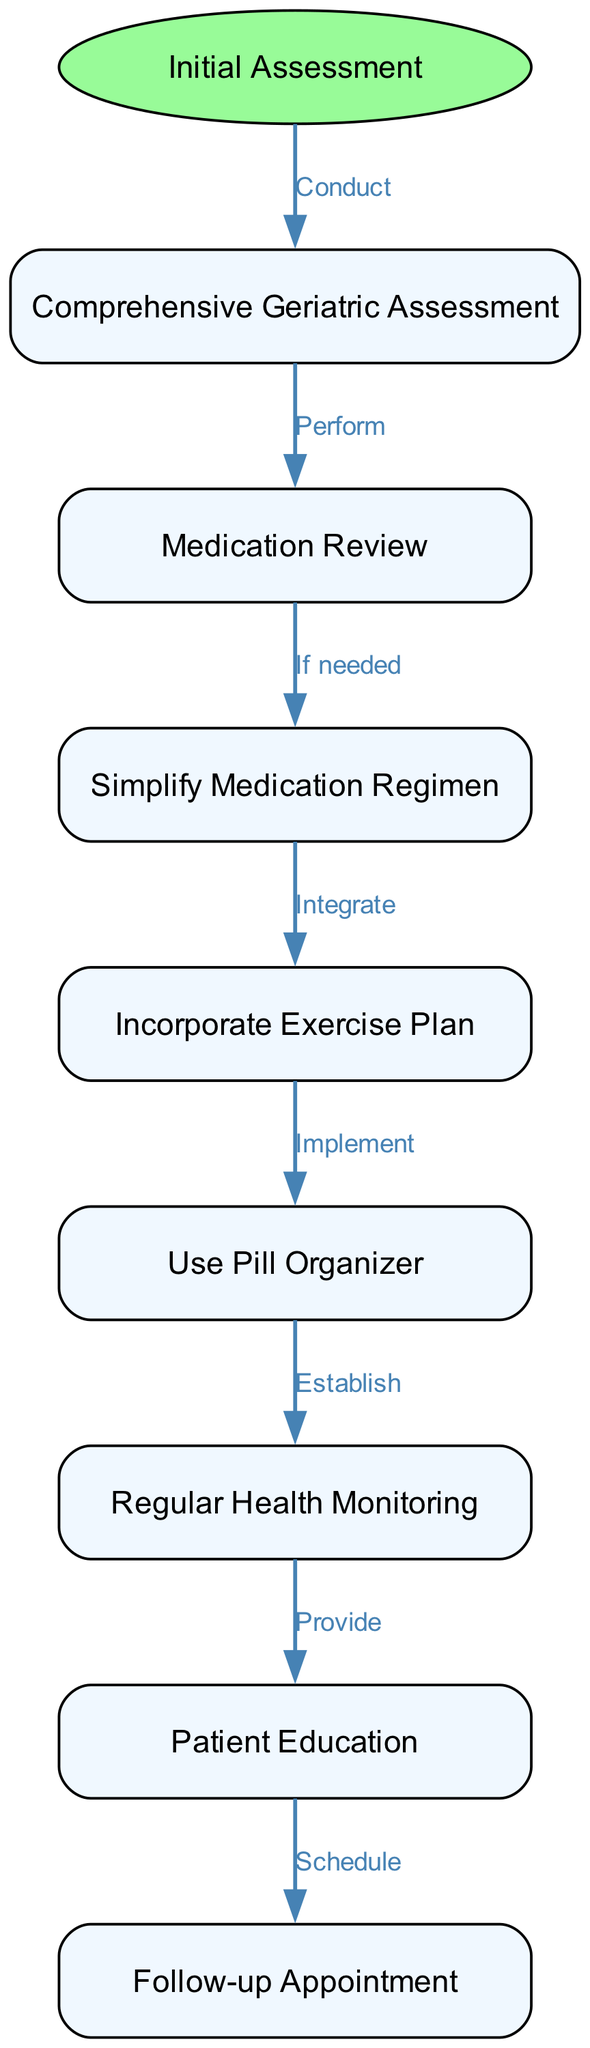How many nodes are in the diagram? The diagram contains nodes for each step in the medication management process, specifically: Initial Assessment, Comprehensive Geriatric Assessment, Medication Review, Simplify Medication Regimen, Incorporate Exercise Plan, Use Pill Organizer, Regular Health Monitoring, Patient Education, and Follow-up Appointment. Counting these, there are a total of 8 nodes.
Answer: 8 What is the first step in the flowchart? The flowchart starts with the "Initial Assessment" node, which indicates the beginning of the medication management process.
Answer: Initial Assessment Which node follows the "Comprehensive Geriatric Assessment"? After the "Comprehensive Geriatric Assessment" node, the next node in the flowchart is "Medication Review". This step follows the assessment process.
Answer: Medication Review What action is taken if a medication review indicates a need for changes? If the medication review indicates changes are needed, the flowchart specifies "Simplify Medication Regimen" as the next step, suggesting that adjustments will be made to the medication plan.
Answer: Simplify Medication Regimen What is scheduled after patient education? Following patient education, the flowchart shows a "Follow-up Appointment" is scheduled, indicating that ongoing care is considered as part of the management process.
Answer: Follow-up Appointment What connects "Use Pill Organizer" to "Regular Health Monitoring"? The relationship between "Use Pill Organizer" and "Regular Health Monitoring" is described in the flowchart by the action "Establish," which implies that establishing the use of a pill organizer leads to regular health monitoring.
Answer: Establish Which step integrates exercise into the medication plan? The step that integrates exercise into the medication plan is "Incorporate Exercise Plan," which is connected to "Simplify Medication Regimen," indicating that after medication simplification, exercise will be introduced.
Answer: Incorporate Exercise Plan How many edges are there in the diagram? The edges in the diagram represent the connections between nodes, showing the flow of the medication management pathway. There are 7 edges indicating the transitions from one node to the next.
Answer: 7 What does "Provide" link to in the diagram? The action "Provide" links "Regular Health Monitoring" to "Patient Education" in the flowchart, indicating that health monitoring will inform the educational efforts for the patient.
Answer: Patient Education 